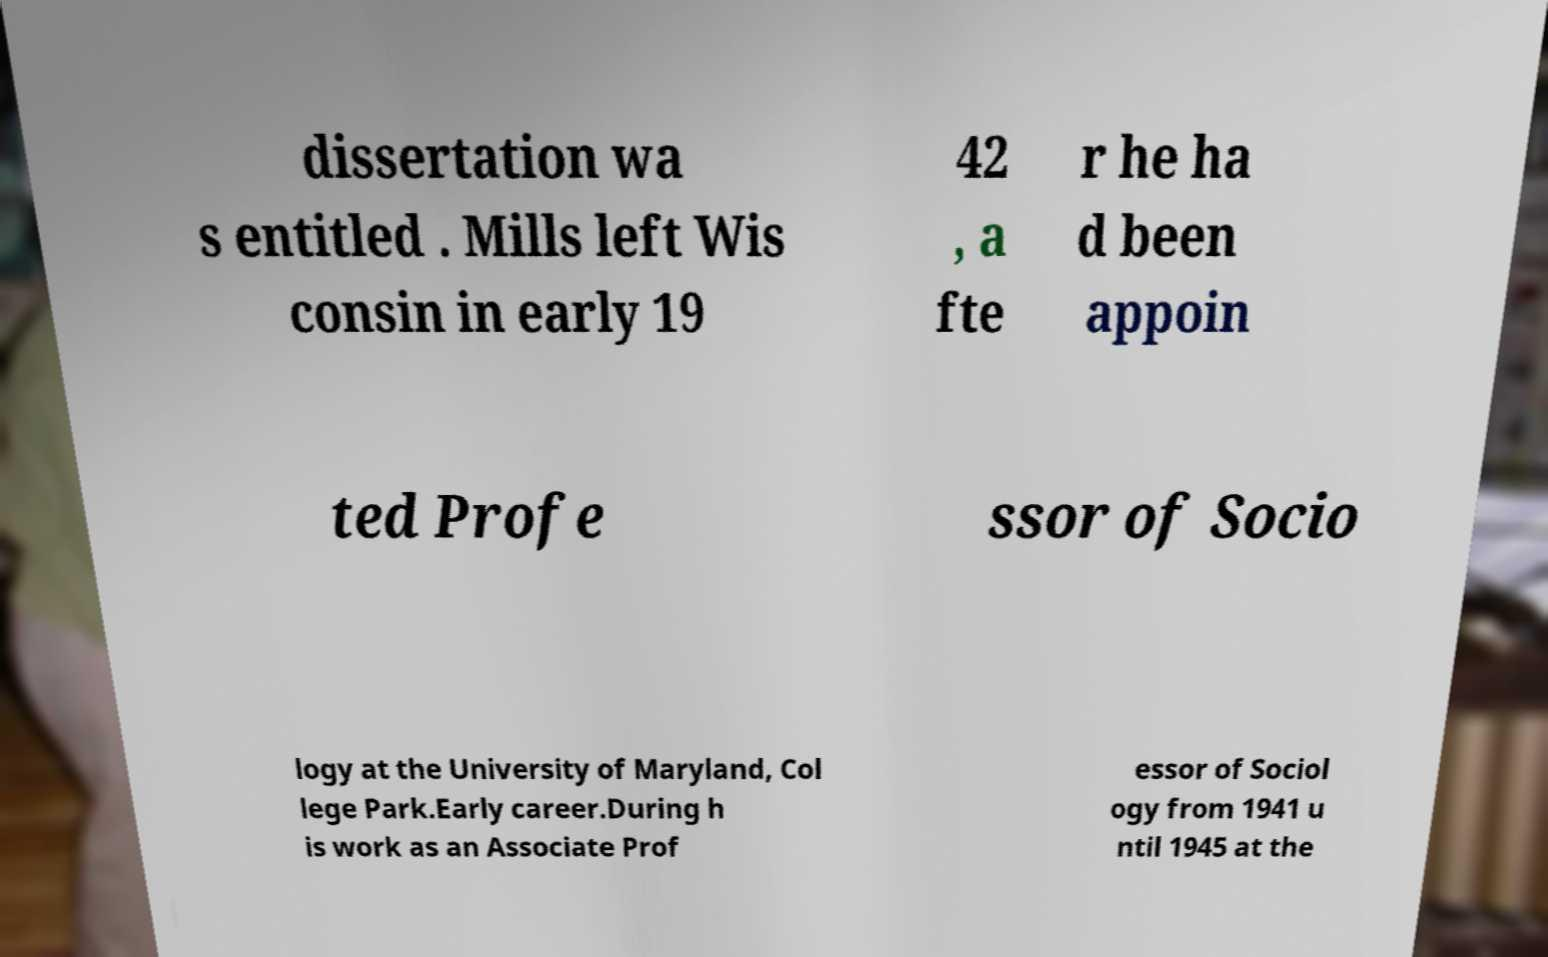Could you assist in decoding the text presented in this image and type it out clearly? dissertation wa s entitled . Mills left Wis consin in early 19 42 , a fte r he ha d been appoin ted Profe ssor of Socio logy at the University of Maryland, Col lege Park.Early career.During h is work as an Associate Prof essor of Sociol ogy from 1941 u ntil 1945 at the 